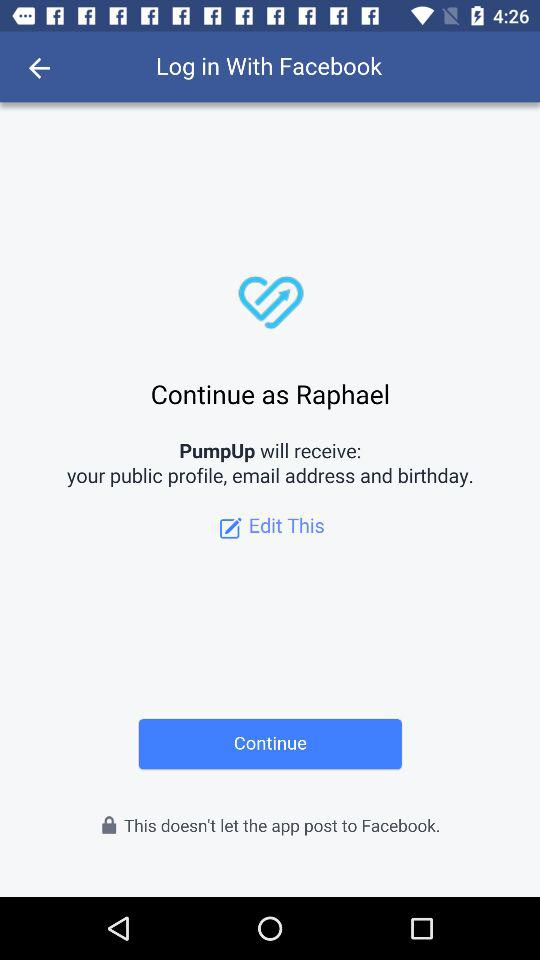How can we log in? You can log in with "Facebook". 